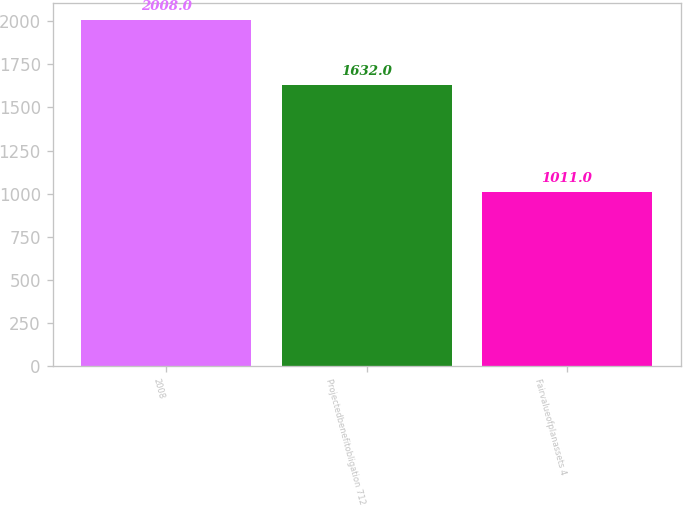Convert chart. <chart><loc_0><loc_0><loc_500><loc_500><bar_chart><fcel>2008<fcel>Projectedbenefitobligation 712<fcel>Fairvalueofplanassets 4<nl><fcel>2008<fcel>1632<fcel>1011<nl></chart> 